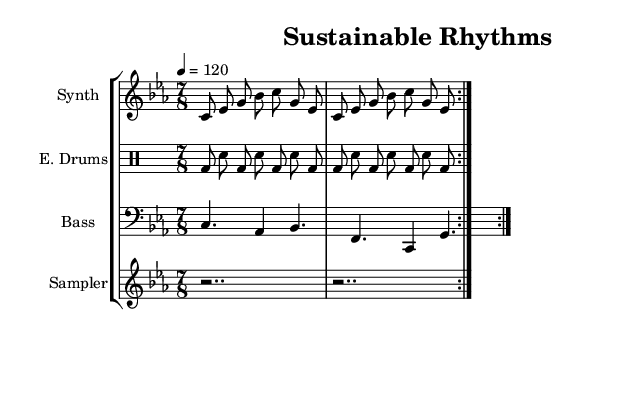What is the key signature of this music? The key signature is indicated at the beginning of the score and shows C minor, which has three flats.
Answer: C minor What is the time signature of this music? The time signature is found at the start of the score and specifies 7/8, indicating seven eighth notes per measure.
Answer: 7/8 What is the tempo of this piece? The tempo marking indicates that the piece should be played at 120 beats per minute, which is shown at the beginning of the score.
Answer: 120 How many measures are repeated in the synth melody? The synth melody has a repeat indication that states to repeat the section two times, marked by "volta 2."
Answer: 2 What is the rhythm pattern for the electronic drums? Analyzing the drummode section, the pattern consists of alternating bass drum and snare drum notes, creating a distinctive rhythmic flow that contributes to the electronic style.
Answer: Bass drum and snare Why is the bass line predominantly composed of dotted rhythms? The bass line uses dotted notes to create a sustained sound that lends depth and texture, which is a characteristic feature of experimental music, emphasizing rhythm and timbre over traditional melody.
Answer: Dotted rhythms 